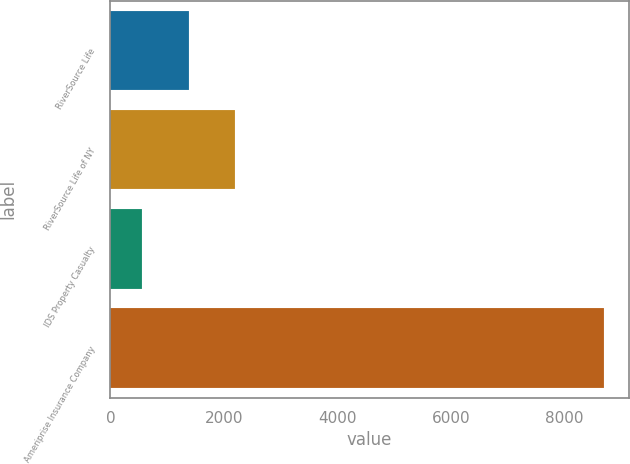Convert chart. <chart><loc_0><loc_0><loc_500><loc_500><bar_chart><fcel>RiverSource Life<fcel>RiverSource Life of NY<fcel>IDS Property Casualty<fcel>Ameriprise Insurance Company<nl><fcel>1376.8<fcel>2190.6<fcel>563<fcel>8701<nl></chart> 